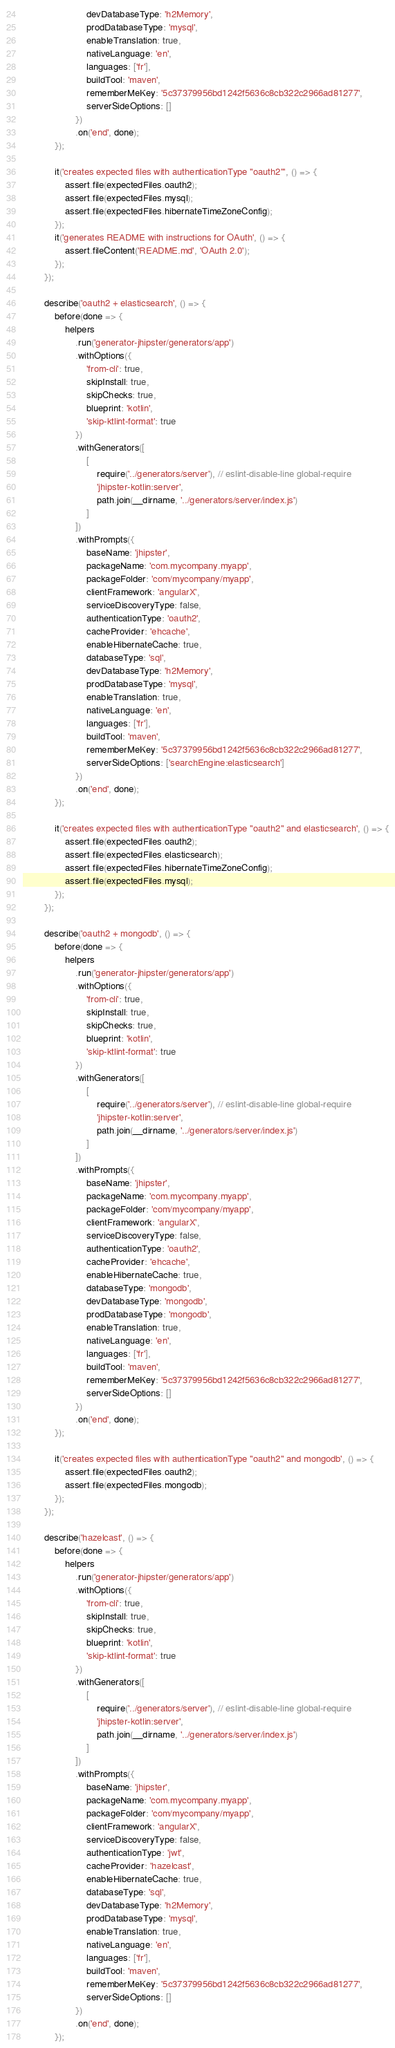<code> <loc_0><loc_0><loc_500><loc_500><_JavaScript_>                        devDatabaseType: 'h2Memory',
                        prodDatabaseType: 'mysql',
                        enableTranslation: true,
                        nativeLanguage: 'en',
                        languages: ['fr'],
                        buildTool: 'maven',
                        rememberMeKey: '5c37379956bd1242f5636c8cb322c2966ad81277',
                        serverSideOptions: []
                    })
                    .on('end', done);
            });

            it('creates expected files with authenticationType "oauth2"', () => {
                assert.file(expectedFiles.oauth2);
                assert.file(expectedFiles.mysql);
                assert.file(expectedFiles.hibernateTimeZoneConfig);
            });
            it('generates README with instructions for OAuth', () => {
                assert.fileContent('README.md', 'OAuth 2.0');
            });
        });

        describe('oauth2 + elasticsearch', () => {
            before(done => {
                helpers
                    .run('generator-jhipster/generators/app')
                    .withOptions({
                        'from-cli': true,
                        skipInstall: true,
                        skipChecks: true,
                        blueprint: 'kotlin',
                        'skip-ktlint-format': true
                    })
                    .withGenerators([
                        [
                            require('../generators/server'), // eslint-disable-line global-require
                            'jhipster-kotlin:server',
                            path.join(__dirname, '../generators/server/index.js')
                        ]
                    ])
                    .withPrompts({
                        baseName: 'jhipster',
                        packageName: 'com.mycompany.myapp',
                        packageFolder: 'com/mycompany/myapp',
                        clientFramework: 'angularX',
                        serviceDiscoveryType: false,
                        authenticationType: 'oauth2',
                        cacheProvider: 'ehcache',
                        enableHibernateCache: true,
                        databaseType: 'sql',
                        devDatabaseType: 'h2Memory',
                        prodDatabaseType: 'mysql',
                        enableTranslation: true,
                        nativeLanguage: 'en',
                        languages: ['fr'],
                        buildTool: 'maven',
                        rememberMeKey: '5c37379956bd1242f5636c8cb322c2966ad81277',
                        serverSideOptions: ['searchEngine:elasticsearch']
                    })
                    .on('end', done);
            });

            it('creates expected files with authenticationType "oauth2" and elasticsearch', () => {
                assert.file(expectedFiles.oauth2);
                assert.file(expectedFiles.elasticsearch);
                assert.file(expectedFiles.hibernateTimeZoneConfig);
                assert.file(expectedFiles.mysql);
            });
        });

        describe('oauth2 + mongodb', () => {
            before(done => {
                helpers
                    .run('generator-jhipster/generators/app')
                    .withOptions({
                        'from-cli': true,
                        skipInstall: true,
                        skipChecks: true,
                        blueprint: 'kotlin',
                        'skip-ktlint-format': true
                    })
                    .withGenerators([
                        [
                            require('../generators/server'), // eslint-disable-line global-require
                            'jhipster-kotlin:server',
                            path.join(__dirname, '../generators/server/index.js')
                        ]
                    ])
                    .withPrompts({
                        baseName: 'jhipster',
                        packageName: 'com.mycompany.myapp',
                        packageFolder: 'com/mycompany/myapp',
                        clientFramework: 'angularX',
                        serviceDiscoveryType: false,
                        authenticationType: 'oauth2',
                        cacheProvider: 'ehcache',
                        enableHibernateCache: true,
                        databaseType: 'mongodb',
                        devDatabaseType: 'mongodb',
                        prodDatabaseType: 'mongodb',
                        enableTranslation: true,
                        nativeLanguage: 'en',
                        languages: ['fr'],
                        buildTool: 'maven',
                        rememberMeKey: '5c37379956bd1242f5636c8cb322c2966ad81277',
                        serverSideOptions: []
                    })
                    .on('end', done);
            });

            it('creates expected files with authenticationType "oauth2" and mongodb', () => {
                assert.file(expectedFiles.oauth2);
                assert.file(expectedFiles.mongodb);
            });
        });

        describe('hazelcast', () => {
            before(done => {
                helpers
                    .run('generator-jhipster/generators/app')
                    .withOptions({
                        'from-cli': true,
                        skipInstall: true,
                        skipChecks: true,
                        blueprint: 'kotlin',
                        'skip-ktlint-format': true
                    })
                    .withGenerators([
                        [
                            require('../generators/server'), // eslint-disable-line global-require
                            'jhipster-kotlin:server',
                            path.join(__dirname, '../generators/server/index.js')
                        ]
                    ])
                    .withPrompts({
                        baseName: 'jhipster',
                        packageName: 'com.mycompany.myapp',
                        packageFolder: 'com/mycompany/myapp',
                        clientFramework: 'angularX',
                        serviceDiscoveryType: false,
                        authenticationType: 'jwt',
                        cacheProvider: 'hazelcast',
                        enableHibernateCache: true,
                        databaseType: 'sql',
                        devDatabaseType: 'h2Memory',
                        prodDatabaseType: 'mysql',
                        enableTranslation: true,
                        nativeLanguage: 'en',
                        languages: ['fr'],
                        buildTool: 'maven',
                        rememberMeKey: '5c37379956bd1242f5636c8cb322c2966ad81277',
                        serverSideOptions: []
                    })
                    .on('end', done);
            });</code> 